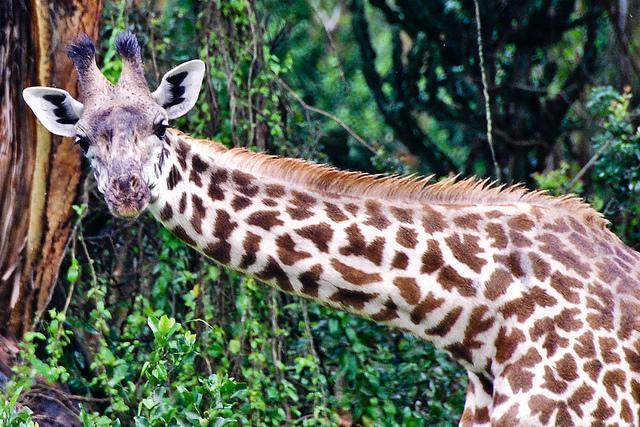How many ears can you see on this animal?
Give a very brief answer. 2. How many giraffes are in the picture?
Give a very brief answer. 1. 